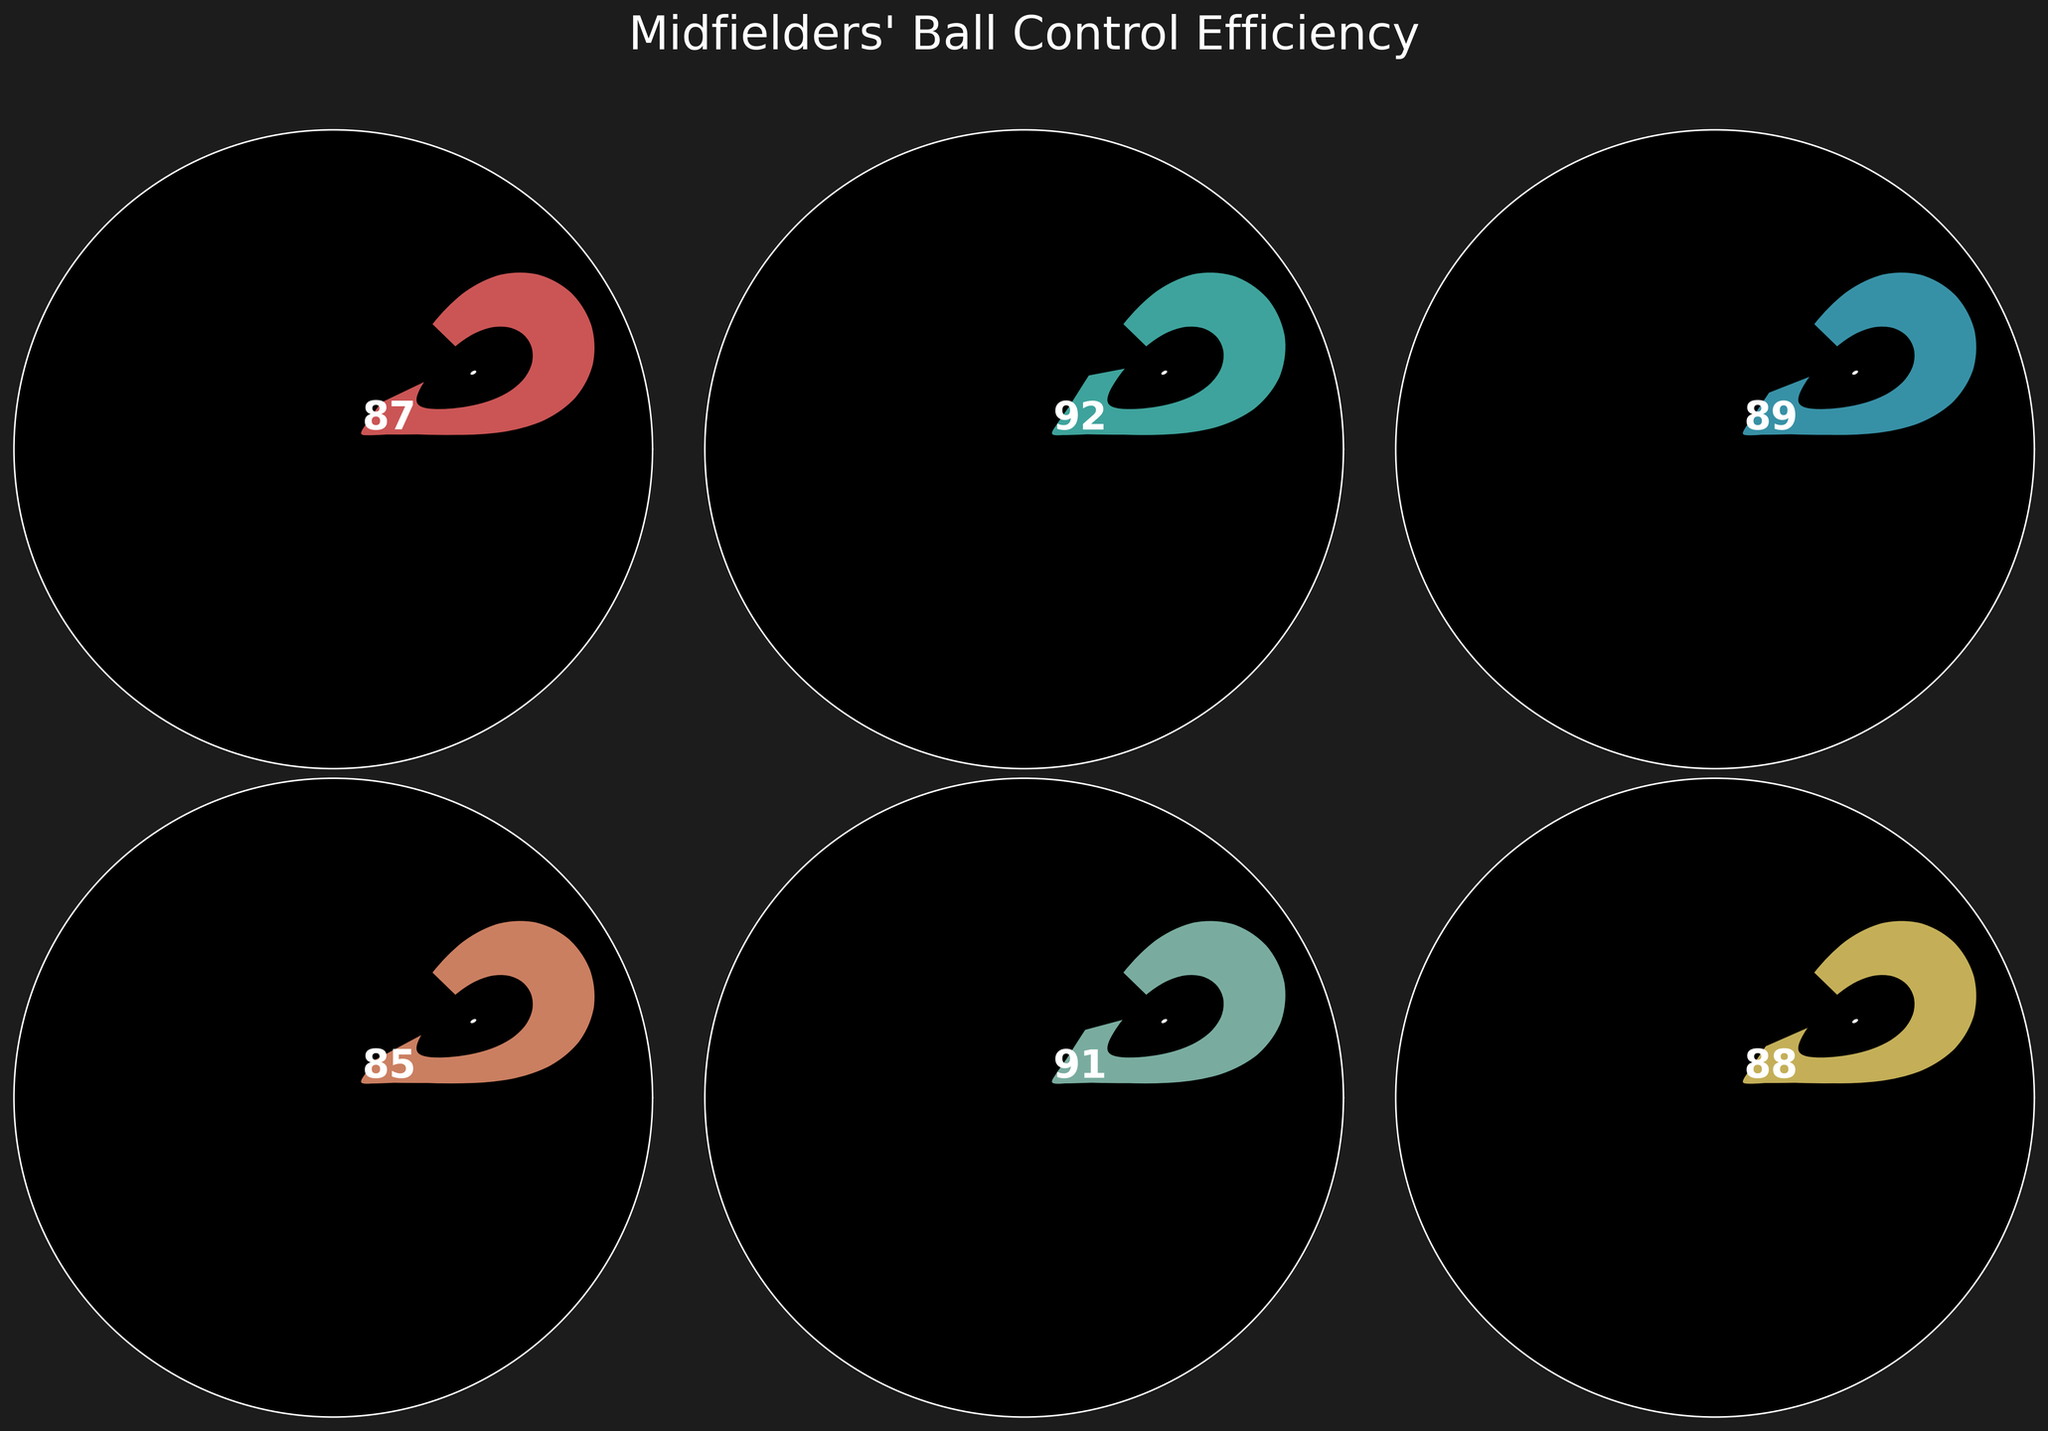What is the title of the figure? The title of the figure is typically displayed at the top of the chart and provides a summary of the visual information presented. In this figure, it is highlighted in large font.
Answer: Midfielders' Ball Control Efficiency How many midfielders' efficiency ratings are shown? By counting the distinct gauge charts, each representing one midfielder, one can determine the number of data points.
Answer: 6 Which player has the highest ball control efficiency? By comparing the numerical values presented on each gauge, the highest value is associated with the player with the peak efficiency. Kevin De Bruyne has a rating of 92, which is the highest among all the players.
Answer: Kevin De Bruyne Is Kevin De Bruyne’s rating higher than your rating? By comparing the values of both Kevin De Bruyne's efficiency (92) and your efficiency (87), it's evident that Kevin De Bruyne's rating is higher.
Answer: Yes What is the difference between the lowest and the highest ball control efficiency ratings? Calculate the highest value (Kevin De Bruyne, 92) minus the lowest value (Thiago Alcantara, 85).
Answer: 7 Which player’s rating is closest to your ball control efficiency? Comparing your rating (87) with the other players' ratings, Bruno Fernandes has a rating of 88 which is the closest.
Answer: Bruno Fernandes What is the average ball control efficiency rating of all players including yours? Summing all the individual ratings (87, 92, 89, 85, 91, 88) and then dividing by the number of data points (6).
Answer: 88.67 How does Thiago Alcantara's ball control efficiency compare to your rating? By comparing the values, Thiago Alcantara has a rating of 85 which is slightly lower than your 87.
Answer: Lower Which players have a ball control efficiency rating higher than 90? Listed players with values greater than 90: Kevin De Bruyne (92) and Frenkie de Jong (91).
Answer: Kevin De Bruyne, Frenkie de Jong Based on the given figure, which player would you say has slightly better ball control efficiency than you? By identifying players with ratings slightly above 87, it is evident that Bruno Fernandes (88) is just slightly better.
Answer: Bruno Fernandes 